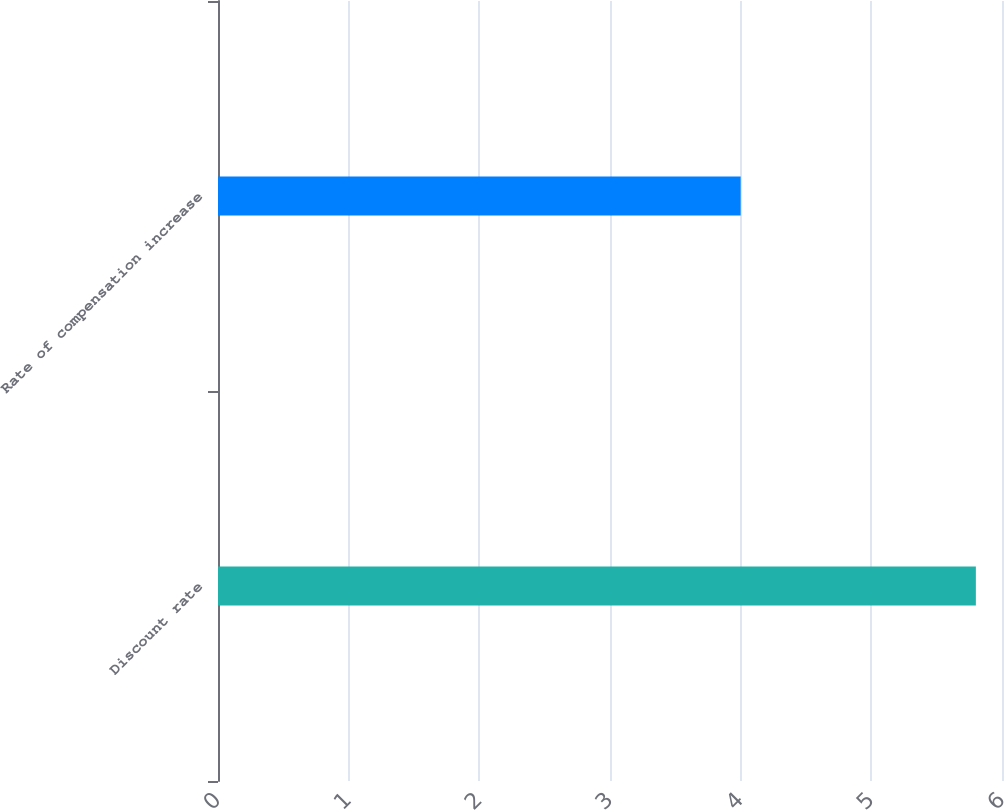<chart> <loc_0><loc_0><loc_500><loc_500><bar_chart><fcel>Discount rate<fcel>Rate of compensation increase<nl><fcel>5.8<fcel>4<nl></chart> 